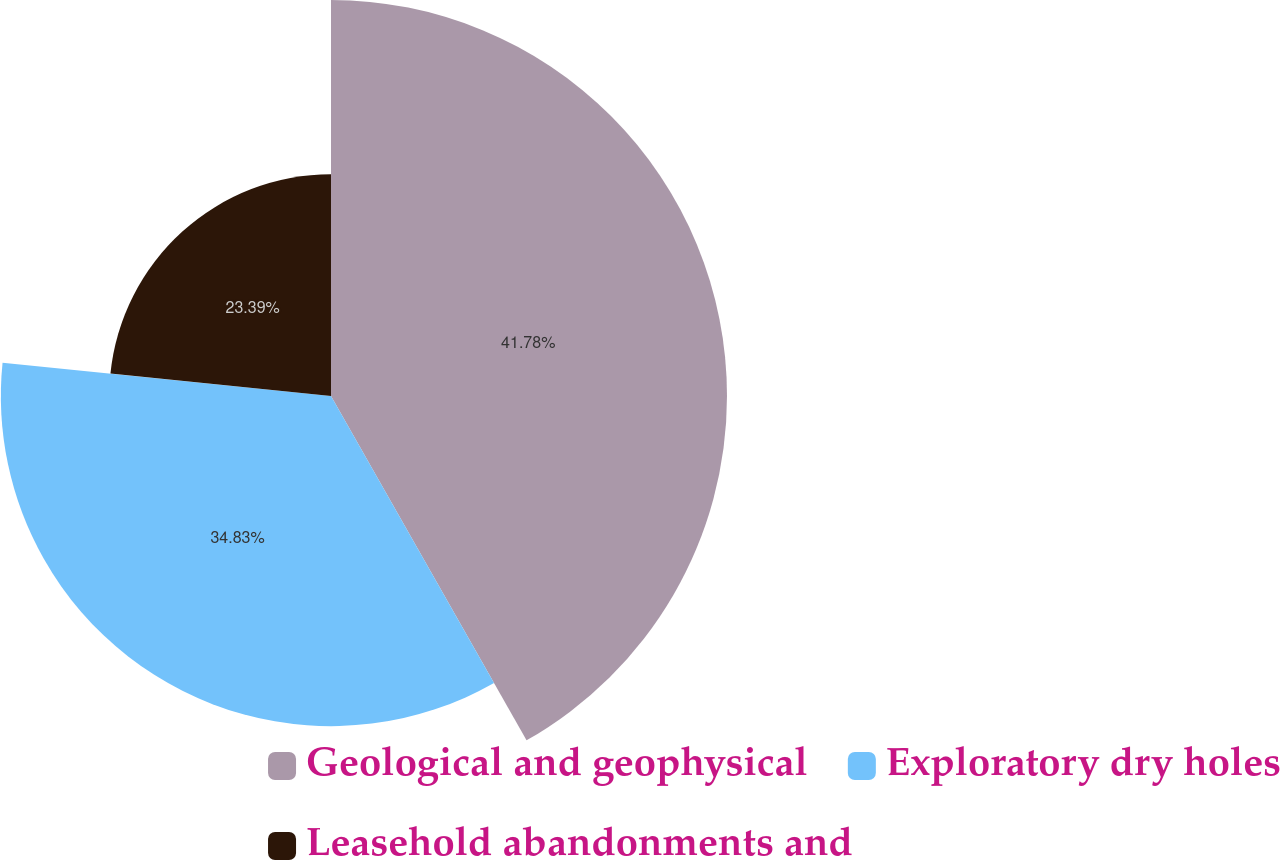Convert chart. <chart><loc_0><loc_0><loc_500><loc_500><pie_chart><fcel>Geological and geophysical<fcel>Exploratory dry holes<fcel>Leasehold abandonments and<nl><fcel>41.78%<fcel>34.83%<fcel>23.39%<nl></chart> 